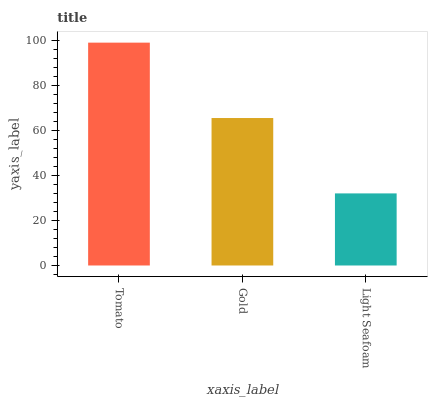Is Gold the minimum?
Answer yes or no. No. Is Gold the maximum?
Answer yes or no. No. Is Tomato greater than Gold?
Answer yes or no. Yes. Is Gold less than Tomato?
Answer yes or no. Yes. Is Gold greater than Tomato?
Answer yes or no. No. Is Tomato less than Gold?
Answer yes or no. No. Is Gold the high median?
Answer yes or no. Yes. Is Gold the low median?
Answer yes or no. Yes. Is Light Seafoam the high median?
Answer yes or no. No. Is Tomato the low median?
Answer yes or no. No. 